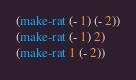<code> <loc_0><loc_0><loc_500><loc_500><_Scheme_>(make-rat (- 1) (- 2))
(make-rat (- 1) 2)
(make-rat 1 (- 2))
</code> 